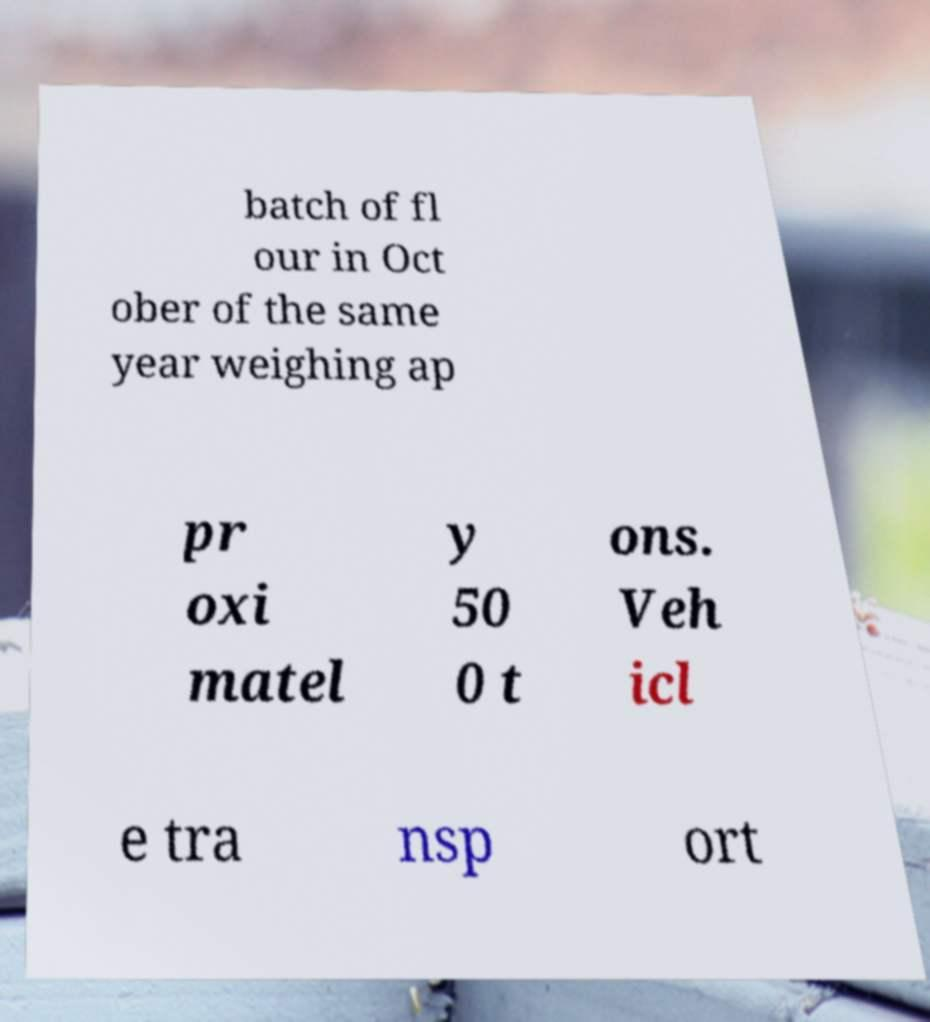There's text embedded in this image that I need extracted. Can you transcribe it verbatim? batch of fl our in Oct ober of the same year weighing ap pr oxi matel y 50 0 t ons. Veh icl e tra nsp ort 